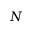Convert formula to latex. <formula><loc_0><loc_0><loc_500><loc_500>N</formula> 